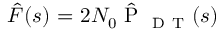<formula> <loc_0><loc_0><loc_500><loc_500>\hat { F } ( s ) = 2 { { N } _ { 0 } } \hat { P } _ { D T } ( s )</formula> 